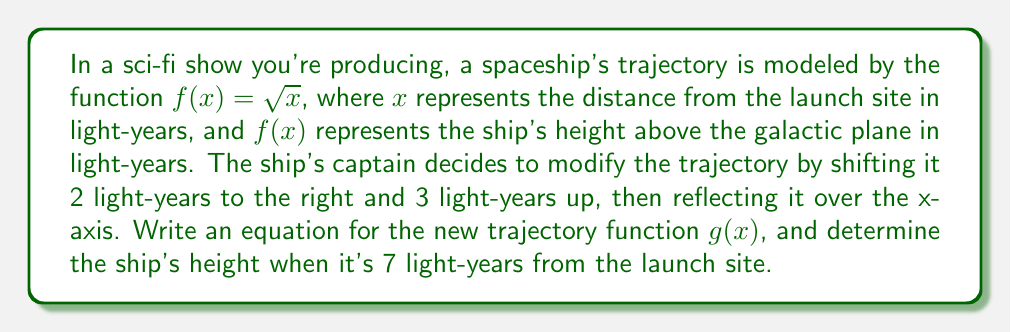Can you solve this math problem? Let's approach this step-by-step:

1) The original function is $f(x) = \sqrt{x}$

2) Shifting 2 light-years to the right:
   This transforms $x$ to $(x-2)$
   $f_1(x) = \sqrt{x-2}$

3) Shifting 3 light-years up:
   This adds 3 to the function
   $f_2(x) = \sqrt{x-2} + 3$

4) Reflecting over the x-axis:
   This negates the function
   $g(x) = -(\sqrt{x-2} + 3)$

5) To simplify:
   $g(x) = -\sqrt{x-2} - 3$

6) To find the height when the ship is 7 light-years from the launch site, we substitute $x=7$:

   $g(7) = -\sqrt{7-2} - 3$
         $= -\sqrt{5} - 3$
         $\approx -5.24$ light-years

The negative value indicates that the ship is below the galactic plane.
Answer: $g(x) = -\sqrt{x-2} - 3$; Height at 7 light-years: $-\sqrt{5} - 3 \approx -5.24$ light-years 